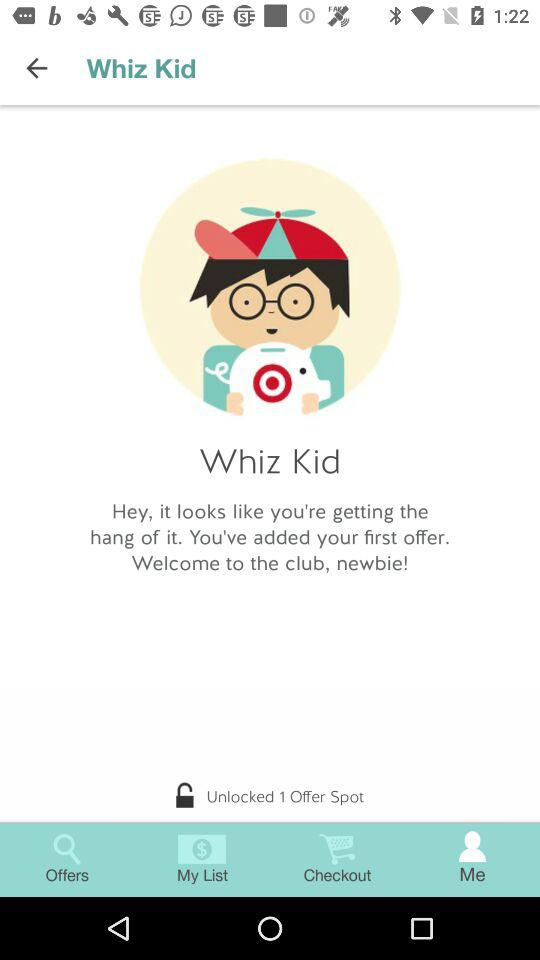How many offers have I unlocked?
Answer the question using a single word or phrase. 1 